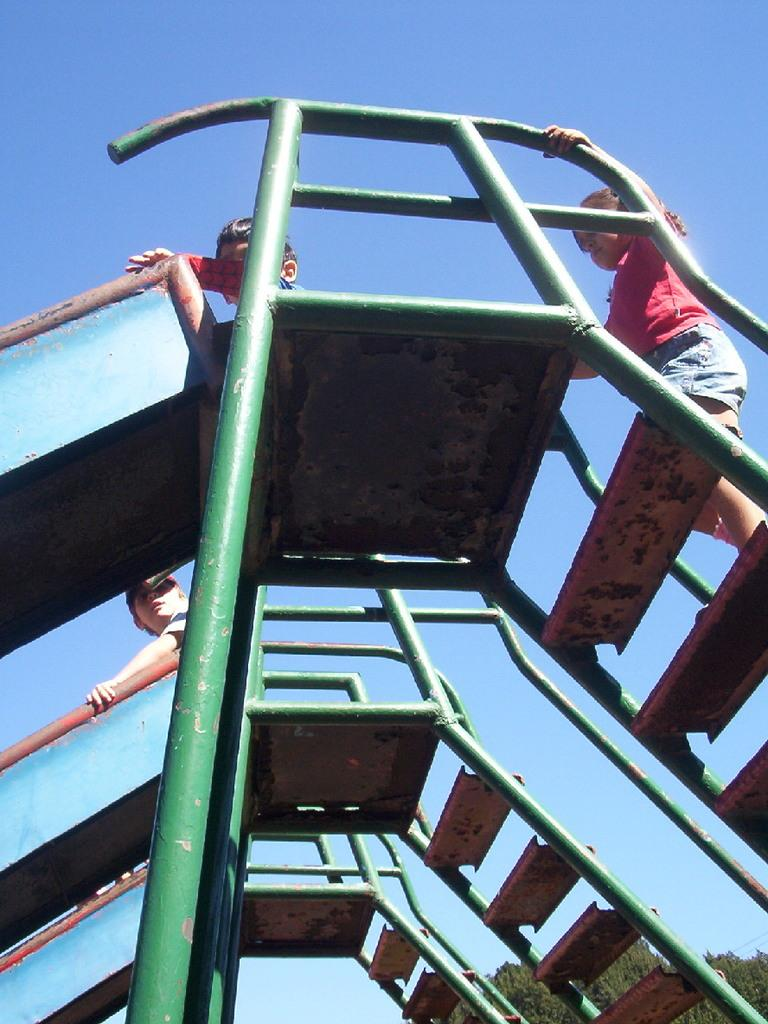What can be seen in the foreground of the image? There are three slides in the foreground of the image. What are the kids doing on the slides? Kids are standing and sitting on the slides. What can be seen in the background of the image? There are trees and the sky visible in the background of the image. What type of team is visible in the image? There is no team present in the image; it features slides and kids. Can you tell me how many deaths occurred in the image? There is no indication of any deaths in the image; it shows kids playing on slides. 